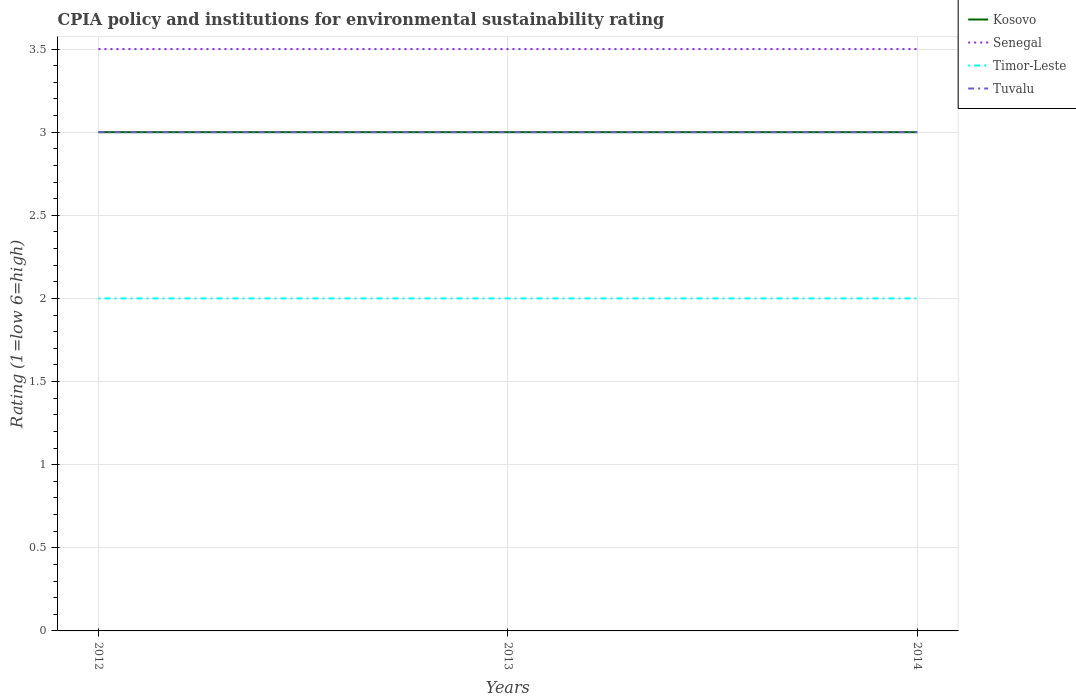Does the line corresponding to Senegal intersect with the line corresponding to Timor-Leste?
Provide a succinct answer. No. Across all years, what is the maximum CPIA rating in Tuvalu?
Keep it short and to the point. 3. What is the total CPIA rating in Tuvalu in the graph?
Provide a short and direct response. 0. What is the difference between the highest and the second highest CPIA rating in Timor-Leste?
Keep it short and to the point. 0. What is the difference between two consecutive major ticks on the Y-axis?
Give a very brief answer. 0.5. Are the values on the major ticks of Y-axis written in scientific E-notation?
Offer a very short reply. No. Does the graph contain any zero values?
Make the answer very short. No. How are the legend labels stacked?
Keep it short and to the point. Vertical. What is the title of the graph?
Your answer should be very brief. CPIA policy and institutions for environmental sustainability rating. Does "Malta" appear as one of the legend labels in the graph?
Keep it short and to the point. No. What is the Rating (1=low 6=high) in Senegal in 2012?
Make the answer very short. 3.5. What is the Rating (1=low 6=high) of Timor-Leste in 2012?
Provide a short and direct response. 2. What is the Rating (1=low 6=high) in Kosovo in 2013?
Provide a short and direct response. 3. What is the Rating (1=low 6=high) of Kosovo in 2014?
Provide a short and direct response. 3. What is the Rating (1=low 6=high) of Tuvalu in 2014?
Your response must be concise. 3. Across all years, what is the maximum Rating (1=low 6=high) of Kosovo?
Your answer should be compact. 3. Across all years, what is the maximum Rating (1=low 6=high) in Senegal?
Give a very brief answer. 3.5. Across all years, what is the maximum Rating (1=low 6=high) in Tuvalu?
Keep it short and to the point. 3. Across all years, what is the minimum Rating (1=low 6=high) in Timor-Leste?
Offer a terse response. 2. What is the total Rating (1=low 6=high) in Timor-Leste in the graph?
Offer a very short reply. 6. What is the difference between the Rating (1=low 6=high) of Kosovo in 2012 and that in 2013?
Give a very brief answer. 0. What is the difference between the Rating (1=low 6=high) of Timor-Leste in 2012 and that in 2013?
Provide a short and direct response. 0. What is the difference between the Rating (1=low 6=high) of Kosovo in 2012 and that in 2014?
Make the answer very short. 0. What is the difference between the Rating (1=low 6=high) of Senegal in 2012 and that in 2014?
Provide a succinct answer. 0. What is the difference between the Rating (1=low 6=high) in Timor-Leste in 2012 and that in 2014?
Your answer should be compact. 0. What is the difference between the Rating (1=low 6=high) of Tuvalu in 2012 and that in 2014?
Provide a short and direct response. 0. What is the difference between the Rating (1=low 6=high) in Kosovo in 2013 and that in 2014?
Ensure brevity in your answer.  0. What is the difference between the Rating (1=low 6=high) in Senegal in 2013 and that in 2014?
Give a very brief answer. 0. What is the difference between the Rating (1=low 6=high) of Timor-Leste in 2013 and that in 2014?
Ensure brevity in your answer.  0. What is the difference between the Rating (1=low 6=high) of Kosovo in 2012 and the Rating (1=low 6=high) of Senegal in 2013?
Your response must be concise. -0.5. What is the difference between the Rating (1=low 6=high) in Kosovo in 2012 and the Rating (1=low 6=high) in Tuvalu in 2013?
Make the answer very short. 0. What is the difference between the Rating (1=low 6=high) in Senegal in 2012 and the Rating (1=low 6=high) in Timor-Leste in 2013?
Your response must be concise. 1.5. What is the difference between the Rating (1=low 6=high) of Senegal in 2012 and the Rating (1=low 6=high) of Timor-Leste in 2014?
Provide a succinct answer. 1.5. What is the difference between the Rating (1=low 6=high) of Senegal in 2012 and the Rating (1=low 6=high) of Tuvalu in 2014?
Provide a succinct answer. 0.5. What is the difference between the Rating (1=low 6=high) in Kosovo in 2013 and the Rating (1=low 6=high) in Timor-Leste in 2014?
Make the answer very short. 1. What is the difference between the Rating (1=low 6=high) in Kosovo in 2013 and the Rating (1=low 6=high) in Tuvalu in 2014?
Your answer should be very brief. 0. What is the average Rating (1=low 6=high) of Kosovo per year?
Give a very brief answer. 3. In the year 2012, what is the difference between the Rating (1=low 6=high) in Senegal and Rating (1=low 6=high) in Timor-Leste?
Your response must be concise. 1.5. In the year 2012, what is the difference between the Rating (1=low 6=high) of Senegal and Rating (1=low 6=high) of Tuvalu?
Make the answer very short. 0.5. In the year 2012, what is the difference between the Rating (1=low 6=high) in Timor-Leste and Rating (1=low 6=high) in Tuvalu?
Offer a very short reply. -1. In the year 2013, what is the difference between the Rating (1=low 6=high) of Kosovo and Rating (1=low 6=high) of Timor-Leste?
Keep it short and to the point. 1. In the year 2013, what is the difference between the Rating (1=low 6=high) of Kosovo and Rating (1=low 6=high) of Tuvalu?
Your answer should be compact. 0. In the year 2013, what is the difference between the Rating (1=low 6=high) in Senegal and Rating (1=low 6=high) in Timor-Leste?
Provide a short and direct response. 1.5. In the year 2013, what is the difference between the Rating (1=low 6=high) of Senegal and Rating (1=low 6=high) of Tuvalu?
Your response must be concise. 0.5. In the year 2014, what is the difference between the Rating (1=low 6=high) of Kosovo and Rating (1=low 6=high) of Senegal?
Provide a short and direct response. -0.5. In the year 2014, what is the difference between the Rating (1=low 6=high) of Kosovo and Rating (1=low 6=high) of Tuvalu?
Offer a terse response. 0. In the year 2014, what is the difference between the Rating (1=low 6=high) in Senegal and Rating (1=low 6=high) in Tuvalu?
Your answer should be compact. 0.5. In the year 2014, what is the difference between the Rating (1=low 6=high) of Timor-Leste and Rating (1=low 6=high) of Tuvalu?
Keep it short and to the point. -1. What is the ratio of the Rating (1=low 6=high) in Kosovo in 2012 to that in 2013?
Provide a short and direct response. 1. What is the ratio of the Rating (1=low 6=high) of Kosovo in 2012 to that in 2014?
Provide a succinct answer. 1. What is the ratio of the Rating (1=low 6=high) of Senegal in 2012 to that in 2014?
Offer a very short reply. 1. What is the ratio of the Rating (1=low 6=high) in Timor-Leste in 2012 to that in 2014?
Ensure brevity in your answer.  1. What is the ratio of the Rating (1=low 6=high) in Timor-Leste in 2013 to that in 2014?
Keep it short and to the point. 1. What is the ratio of the Rating (1=low 6=high) of Tuvalu in 2013 to that in 2014?
Ensure brevity in your answer.  1. What is the difference between the highest and the second highest Rating (1=low 6=high) of Kosovo?
Keep it short and to the point. 0. What is the difference between the highest and the second highest Rating (1=low 6=high) in Timor-Leste?
Make the answer very short. 0. What is the difference between the highest and the second highest Rating (1=low 6=high) in Tuvalu?
Offer a terse response. 0. What is the difference between the highest and the lowest Rating (1=low 6=high) of Senegal?
Offer a very short reply. 0. What is the difference between the highest and the lowest Rating (1=low 6=high) in Timor-Leste?
Provide a short and direct response. 0. 